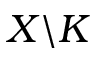<formula> <loc_0><loc_0><loc_500><loc_500>X \ K</formula> 